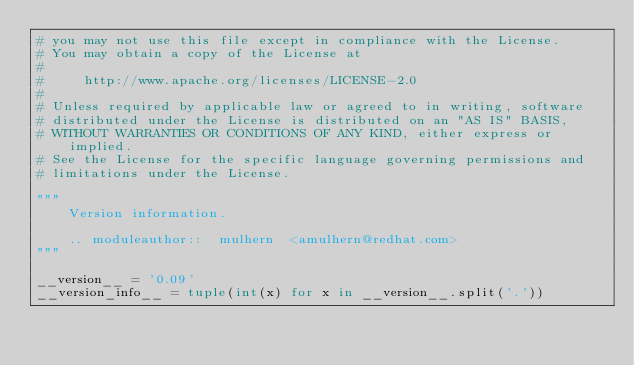Convert code to text. <code><loc_0><loc_0><loc_500><loc_500><_Python_># you may not use this file except in compliance with the License.
# You may obtain a copy of the License at
#
#     http://www.apache.org/licenses/LICENSE-2.0
#
# Unless required by applicable law or agreed to in writing, software
# distributed under the License is distributed on an "AS IS" BASIS,
# WITHOUT WARRANTIES OR CONDITIONS OF ANY KIND, either express or implied.
# See the License for the specific language governing permissions and
# limitations under the License.

"""
    Version information.

    .. moduleauthor::  mulhern  <amulhern@redhat.com>
"""

__version__ = '0.09'
__version_info__ = tuple(int(x) for x in __version__.split('.'))
</code> 